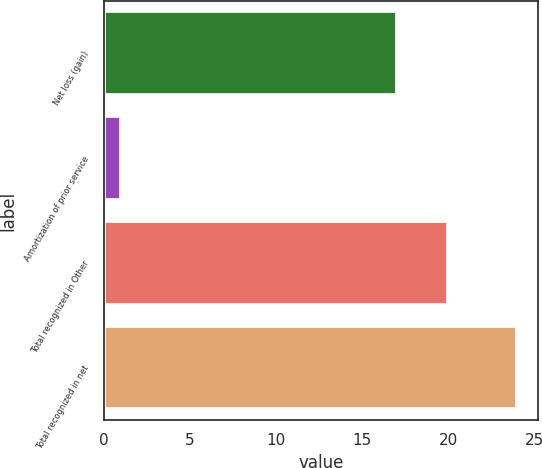Convert chart to OTSL. <chart><loc_0><loc_0><loc_500><loc_500><bar_chart><fcel>Net loss (gain)<fcel>Amortization of prior service<fcel>Total recognized in Other<fcel>Total recognized in net<nl><fcel>17<fcel>1<fcel>20<fcel>24<nl></chart> 